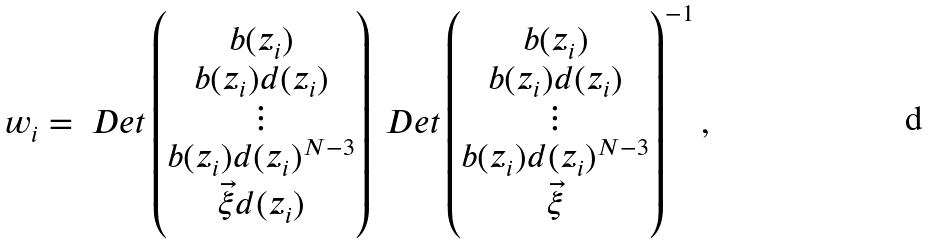<formula> <loc_0><loc_0><loc_500><loc_500>w _ { i } = \ D e t \begin{pmatrix} b ( z _ { i } ) \\ b ( z _ { i } ) d ( z _ { i } ) \\ \vdots \\ b ( z _ { i } ) d ( z _ { i } ) ^ { N - 3 } \\ \vec { \xi } d ( z _ { i } ) \\ \end{pmatrix} \ D e t \begin{pmatrix} b ( z _ { i } ) \\ b ( z _ { i } ) d ( z _ { i } ) \\ \vdots \\ b ( z _ { i } ) d ( z _ { i } ) ^ { N - 3 } \\ \vec { \xi } \\ \end{pmatrix} ^ { - 1 } ,</formula> 